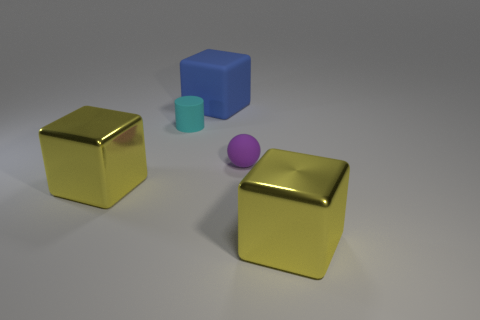Add 2 large rubber cubes. How many objects exist? 7 Subtract all cubes. How many objects are left? 2 Add 5 small purple matte balls. How many small purple matte balls are left? 6 Add 5 small blue matte cylinders. How many small blue matte cylinders exist? 5 Subtract 0 green cylinders. How many objects are left? 5 Subtract all small red matte balls. Subtract all tiny cyan cylinders. How many objects are left? 4 